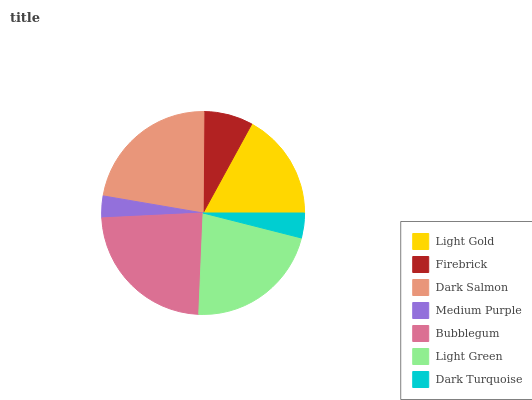Is Medium Purple the minimum?
Answer yes or no. Yes. Is Bubblegum the maximum?
Answer yes or no. Yes. Is Firebrick the minimum?
Answer yes or no. No. Is Firebrick the maximum?
Answer yes or no. No. Is Light Gold greater than Firebrick?
Answer yes or no. Yes. Is Firebrick less than Light Gold?
Answer yes or no. Yes. Is Firebrick greater than Light Gold?
Answer yes or no. No. Is Light Gold less than Firebrick?
Answer yes or no. No. Is Light Gold the high median?
Answer yes or no. Yes. Is Light Gold the low median?
Answer yes or no. Yes. Is Medium Purple the high median?
Answer yes or no. No. Is Dark Turquoise the low median?
Answer yes or no. No. 